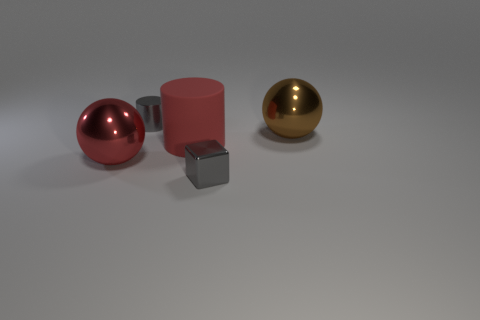How many gray cylinders have the same size as the cube?
Give a very brief answer. 1. What shape is the small object behind the big metallic thing on the right side of the cube?
Make the answer very short. Cylinder. What is the shape of the object left of the gray shiny object that is behind the small thing that is in front of the red metallic thing?
Provide a short and direct response. Sphere. How many red rubber objects are the same shape as the red metal thing?
Your answer should be compact. 0. There is a gray metal object in front of the gray metal cylinder; how many big objects are on the right side of it?
Offer a terse response. 1. What number of rubber things are either small gray cylinders or big spheres?
Provide a short and direct response. 0. Is there a big cyan sphere that has the same material as the brown ball?
Provide a short and direct response. No. How many objects are either things that are to the left of the gray cube or objects to the right of the cube?
Your answer should be compact. 4. There is a shiny sphere in front of the large brown object; does it have the same color as the large matte cylinder?
Make the answer very short. Yes. How many other objects are the same color as the small metallic cylinder?
Provide a short and direct response. 1. 